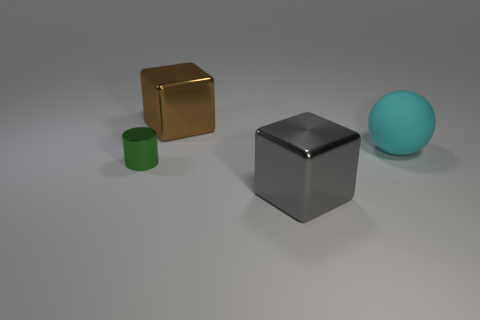Are there any other things that are the same size as the gray metallic block?
Offer a very short reply. Yes. Is the number of tiny cyan metal cylinders less than the number of large brown objects?
Provide a short and direct response. Yes. What number of other objects are there of the same color as the large rubber sphere?
Offer a terse response. 0. How many large cyan blocks are there?
Ensure brevity in your answer.  0. Are there fewer cyan things that are behind the cylinder than small cyan rubber spheres?
Offer a terse response. No. Is the block to the left of the gray metal thing made of the same material as the big gray cube?
Give a very brief answer. Yes. There is a big thing that is in front of the small green metallic cylinder that is behind the large metal cube that is in front of the matte thing; what shape is it?
Ensure brevity in your answer.  Cube. Is there a gray metal thing that has the same size as the cyan matte ball?
Your response must be concise. Yes. What is the size of the brown thing?
Make the answer very short. Large. How many gray objects are the same size as the brown metal object?
Your response must be concise. 1. 